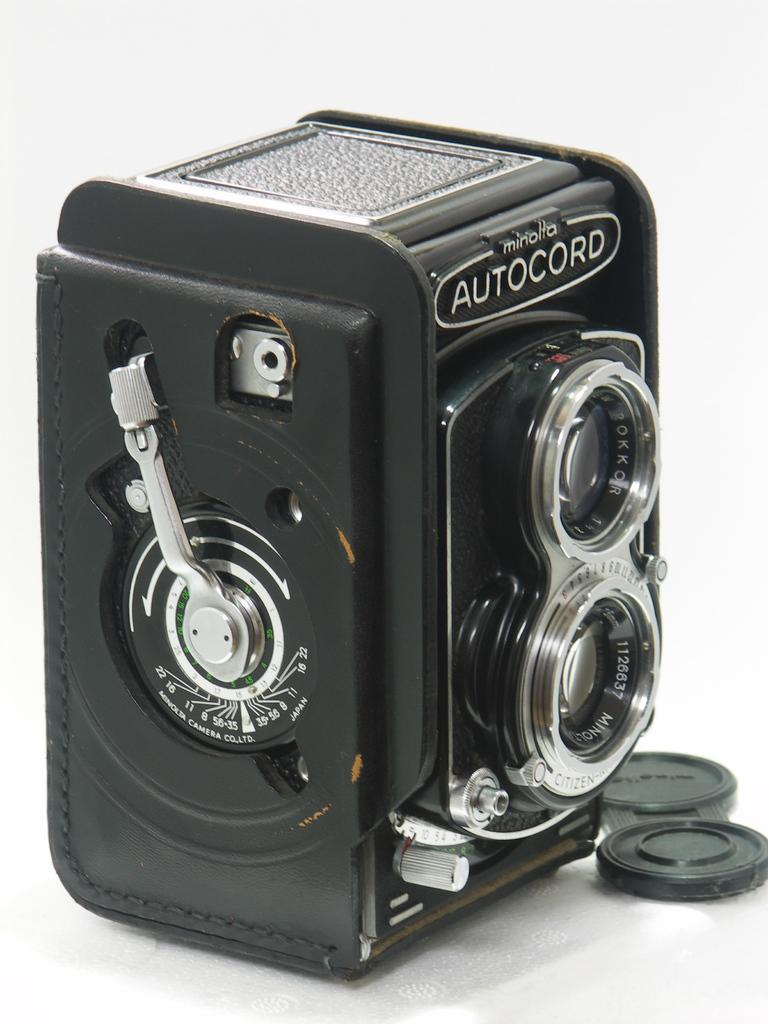What is the main object in the image? There is a beat box in the image. Where is the beat box located? The beat box is on the floor. What color is the beat box? The beat box is black in color. How many kittens are playing on the hall in the image? There are no kittens or halls present in the image; it features a beat box on the floor. 